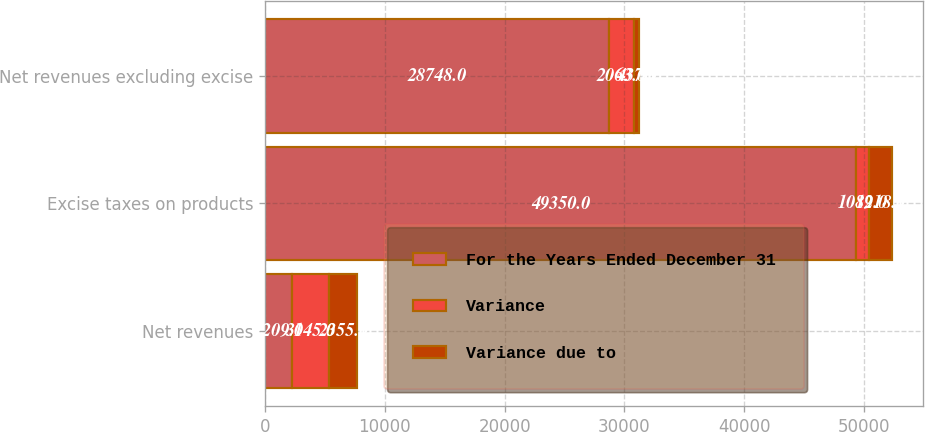Convert chart. <chart><loc_0><loc_0><loc_500><loc_500><stacked_bar_chart><ecel><fcel>Net revenues<fcel>Excise taxes on products<fcel>Net revenues excluding excise<nl><fcel>For the Years Ended December 31<fcel>2209<fcel>49350<fcel>28748<nl><fcel>Variance<fcel>3145<fcel>1082<fcel>2063<nl><fcel>Variance due to<fcel>2355<fcel>1918<fcel>437<nl></chart> 